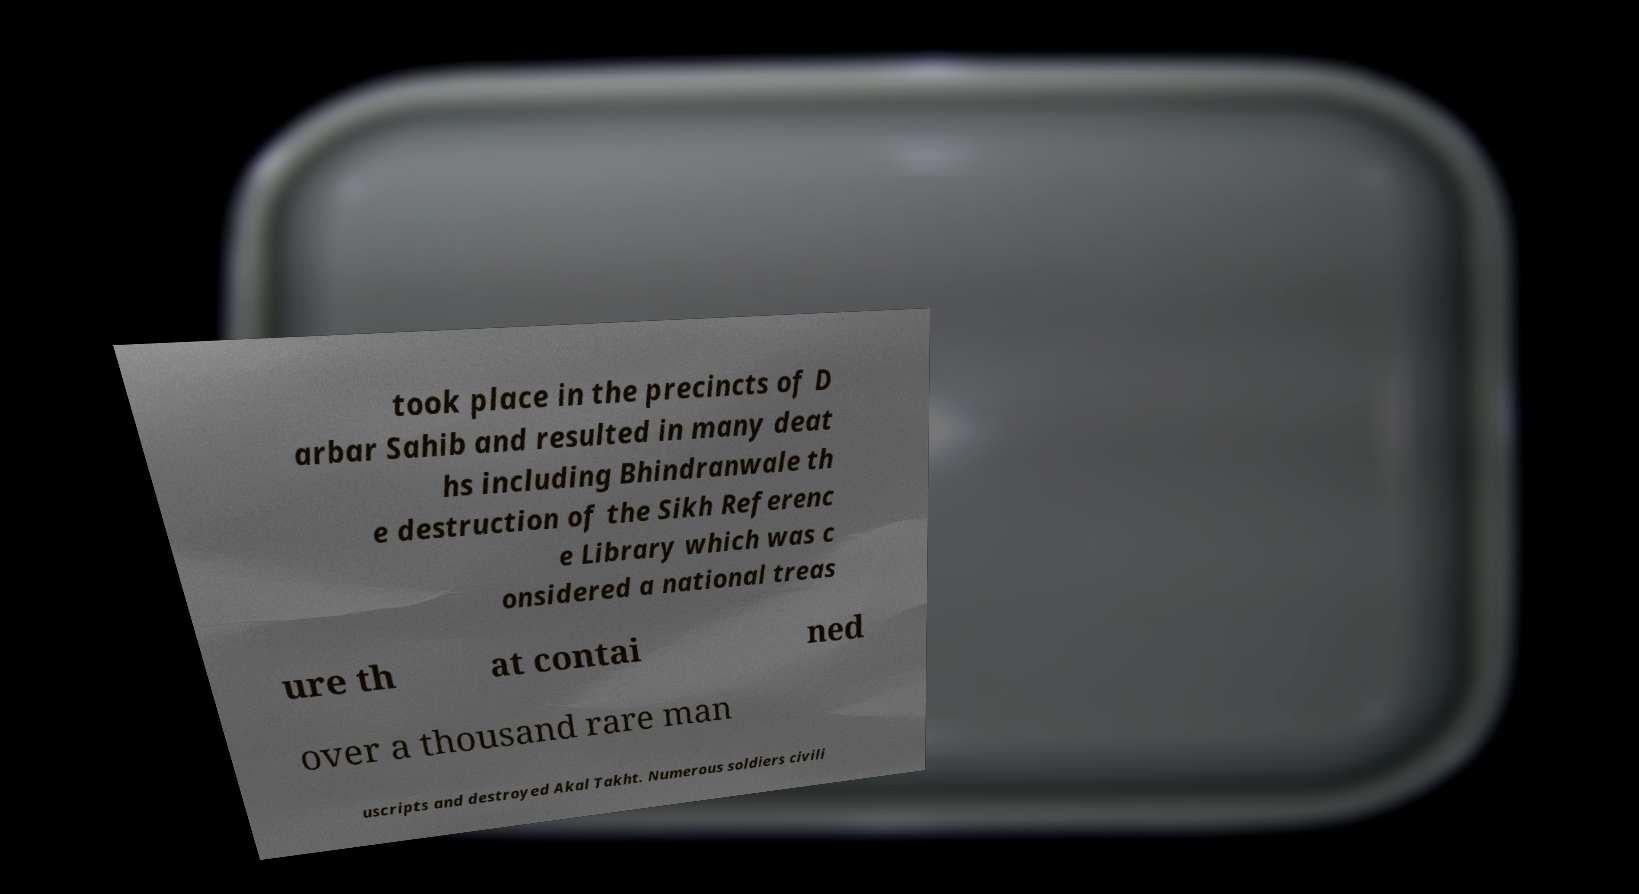There's text embedded in this image that I need extracted. Can you transcribe it verbatim? took place in the precincts of D arbar Sahib and resulted in many deat hs including Bhindranwale th e destruction of the Sikh Referenc e Library which was c onsidered a national treas ure th at contai ned over a thousand rare man uscripts and destroyed Akal Takht. Numerous soldiers civili 